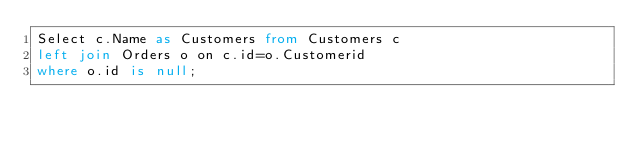<code> <loc_0><loc_0><loc_500><loc_500><_SQL_>Select c.Name as Customers from Customers c
left join Orders o on c.id=o.Customerid
where o.id is null;</code> 